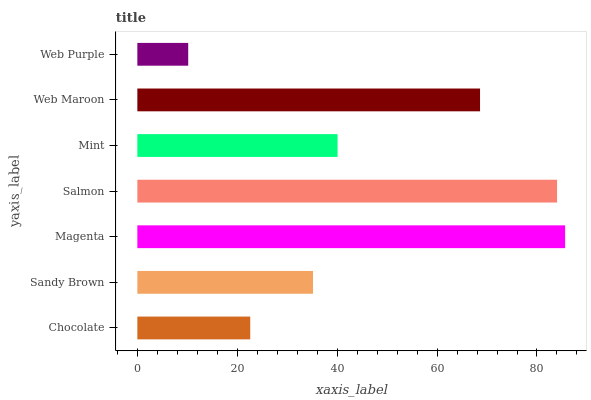Is Web Purple the minimum?
Answer yes or no. Yes. Is Magenta the maximum?
Answer yes or no. Yes. Is Sandy Brown the minimum?
Answer yes or no. No. Is Sandy Brown the maximum?
Answer yes or no. No. Is Sandy Brown greater than Chocolate?
Answer yes or no. Yes. Is Chocolate less than Sandy Brown?
Answer yes or no. Yes. Is Chocolate greater than Sandy Brown?
Answer yes or no. No. Is Sandy Brown less than Chocolate?
Answer yes or no. No. Is Mint the high median?
Answer yes or no. Yes. Is Mint the low median?
Answer yes or no. Yes. Is Web Purple the high median?
Answer yes or no. No. Is Web Maroon the low median?
Answer yes or no. No. 